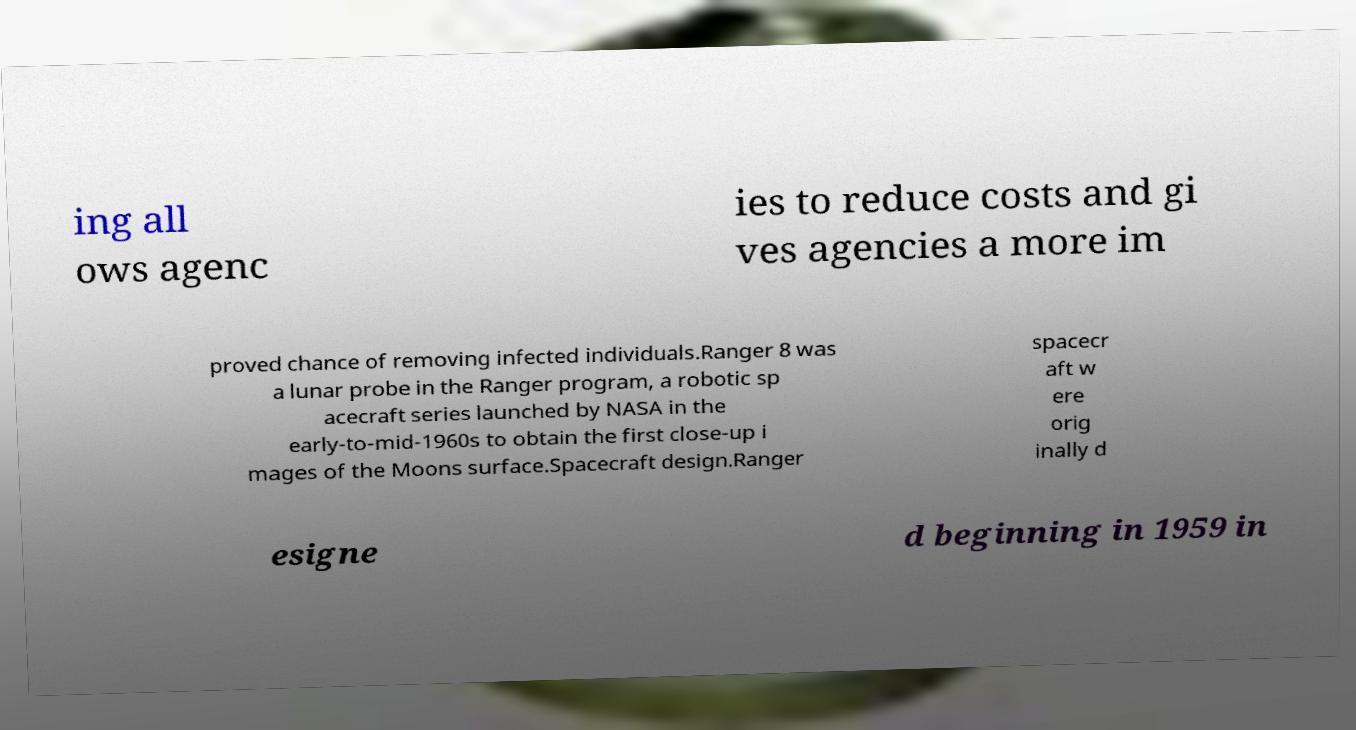Could you assist in decoding the text presented in this image and type it out clearly? ing all ows agenc ies to reduce costs and gi ves agencies a more im proved chance of removing infected individuals.Ranger 8 was a lunar probe in the Ranger program, a robotic sp acecraft series launched by NASA in the early-to-mid-1960s to obtain the first close-up i mages of the Moons surface.Spacecraft design.Ranger spacecr aft w ere orig inally d esigne d beginning in 1959 in 